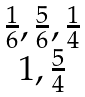Convert formula to latex. <formula><loc_0><loc_0><loc_500><loc_500>\begin{matrix} \frac { 1 } { 6 } , \frac { 5 } { 6 } , \frac { 1 } { 4 } \\ 1 , \frac { 5 } { 4 } \end{matrix}</formula> 